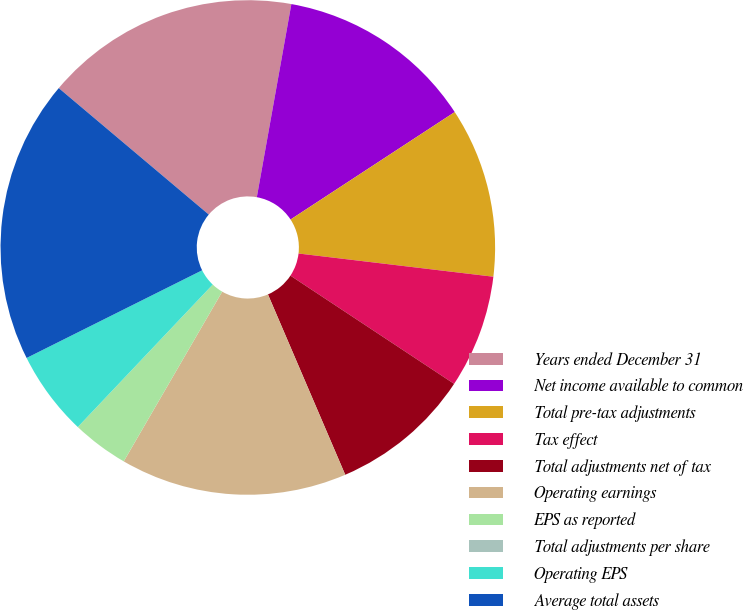Convert chart to OTSL. <chart><loc_0><loc_0><loc_500><loc_500><pie_chart><fcel>Years ended December 31<fcel>Net income available to common<fcel>Total pre-tax adjustments<fcel>Tax effect<fcel>Total adjustments net of tax<fcel>Operating earnings<fcel>EPS as reported<fcel>Total adjustments per share<fcel>Operating EPS<fcel>Average total assets<nl><fcel>16.67%<fcel>12.96%<fcel>11.11%<fcel>7.41%<fcel>9.26%<fcel>14.81%<fcel>3.7%<fcel>0.0%<fcel>5.56%<fcel>18.52%<nl></chart> 